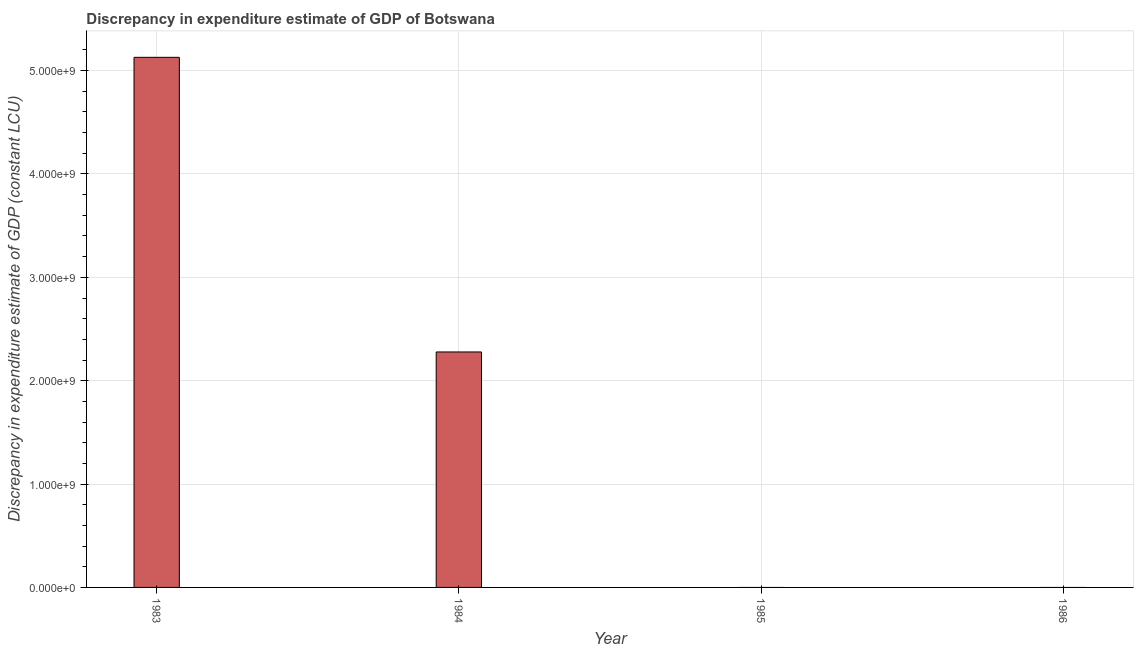Does the graph contain any zero values?
Give a very brief answer. Yes. What is the title of the graph?
Your answer should be compact. Discrepancy in expenditure estimate of GDP of Botswana. What is the label or title of the X-axis?
Offer a terse response. Year. What is the label or title of the Y-axis?
Provide a succinct answer. Discrepancy in expenditure estimate of GDP (constant LCU). What is the discrepancy in expenditure estimate of gdp in 1984?
Ensure brevity in your answer.  2.28e+09. Across all years, what is the maximum discrepancy in expenditure estimate of gdp?
Give a very brief answer. 5.13e+09. Across all years, what is the minimum discrepancy in expenditure estimate of gdp?
Give a very brief answer. 0. In which year was the discrepancy in expenditure estimate of gdp maximum?
Provide a succinct answer. 1983. What is the sum of the discrepancy in expenditure estimate of gdp?
Keep it short and to the point. 7.41e+09. What is the difference between the discrepancy in expenditure estimate of gdp in 1983 and 1984?
Provide a succinct answer. 2.85e+09. What is the average discrepancy in expenditure estimate of gdp per year?
Your answer should be very brief. 1.85e+09. What is the median discrepancy in expenditure estimate of gdp?
Offer a terse response. 1.14e+09. In how many years, is the discrepancy in expenditure estimate of gdp greater than 200000000 LCU?
Give a very brief answer. 2. What is the ratio of the discrepancy in expenditure estimate of gdp in 1983 to that in 1984?
Your answer should be compact. 2.25. Is the sum of the discrepancy in expenditure estimate of gdp in 1983 and 1984 greater than the maximum discrepancy in expenditure estimate of gdp across all years?
Make the answer very short. Yes. What is the difference between the highest and the lowest discrepancy in expenditure estimate of gdp?
Ensure brevity in your answer.  5.13e+09. In how many years, is the discrepancy in expenditure estimate of gdp greater than the average discrepancy in expenditure estimate of gdp taken over all years?
Your response must be concise. 2. What is the Discrepancy in expenditure estimate of GDP (constant LCU) of 1983?
Give a very brief answer. 5.13e+09. What is the Discrepancy in expenditure estimate of GDP (constant LCU) of 1984?
Give a very brief answer. 2.28e+09. What is the Discrepancy in expenditure estimate of GDP (constant LCU) in 1985?
Offer a very short reply. 0. What is the difference between the Discrepancy in expenditure estimate of GDP (constant LCU) in 1983 and 1984?
Provide a short and direct response. 2.85e+09. What is the ratio of the Discrepancy in expenditure estimate of GDP (constant LCU) in 1983 to that in 1984?
Your response must be concise. 2.25. 